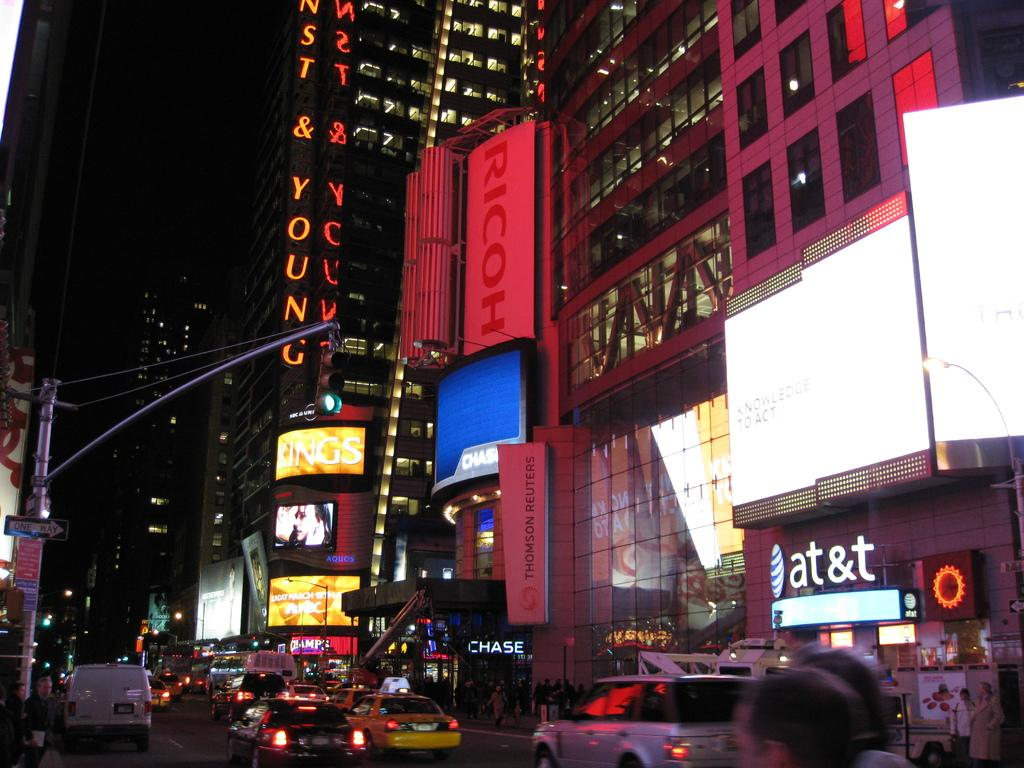<image>
Summarize the visual content of the image. A sign showing the distance to Alice Springs and Maynard stands in the desert. 